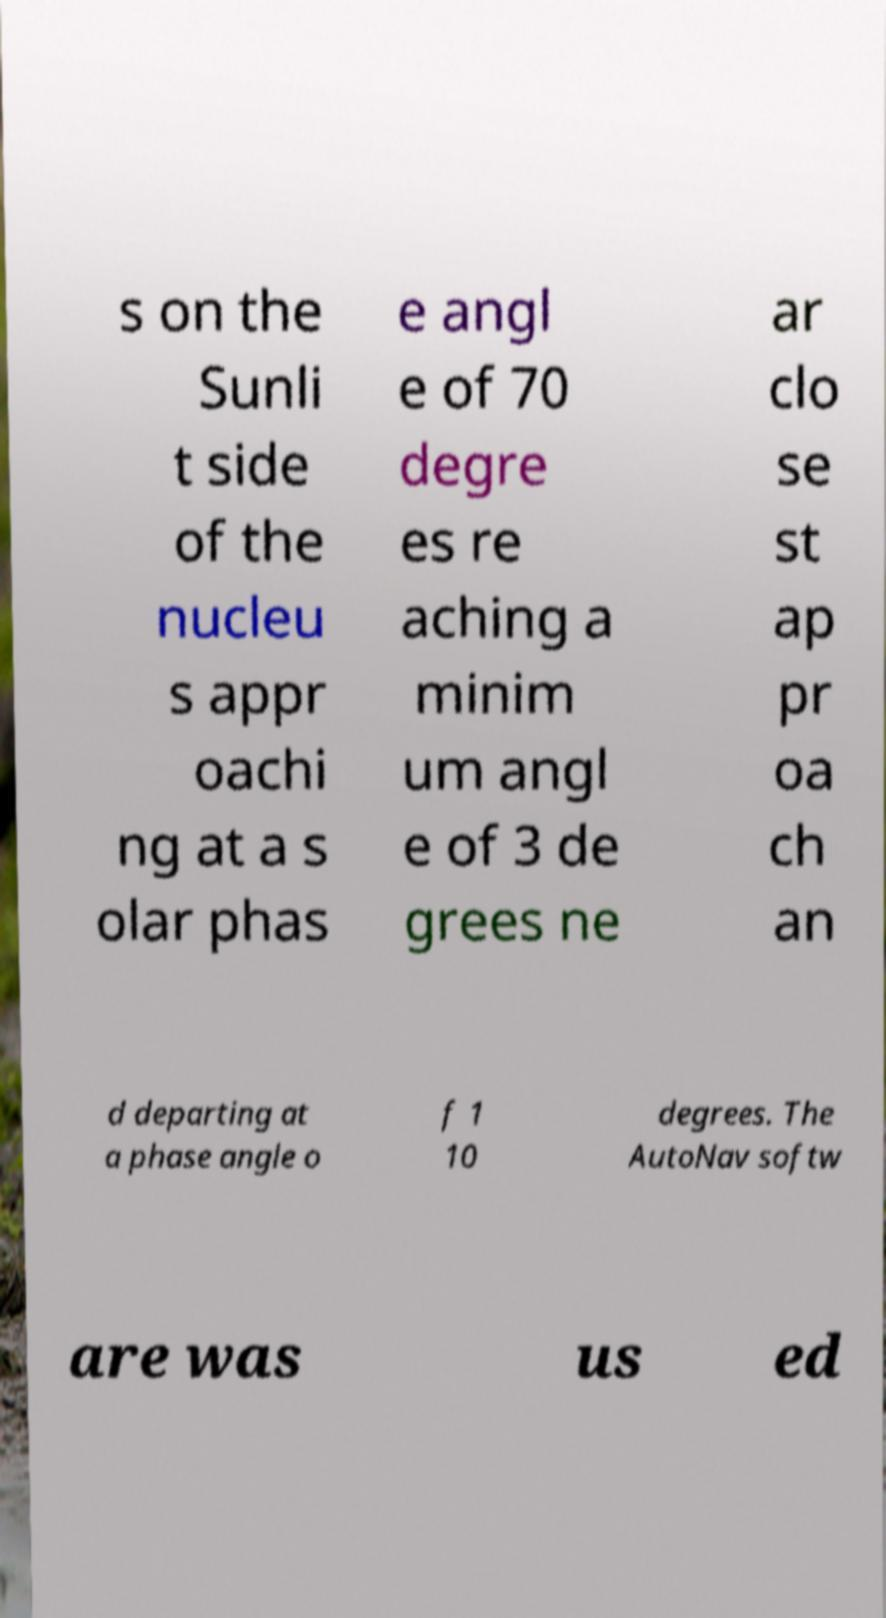Please identify and transcribe the text found in this image. s on the Sunli t side of the nucleu s appr oachi ng at a s olar phas e angl e of 70 degre es re aching a minim um angl e of 3 de grees ne ar clo se st ap pr oa ch an d departing at a phase angle o f 1 10 degrees. The AutoNav softw are was us ed 